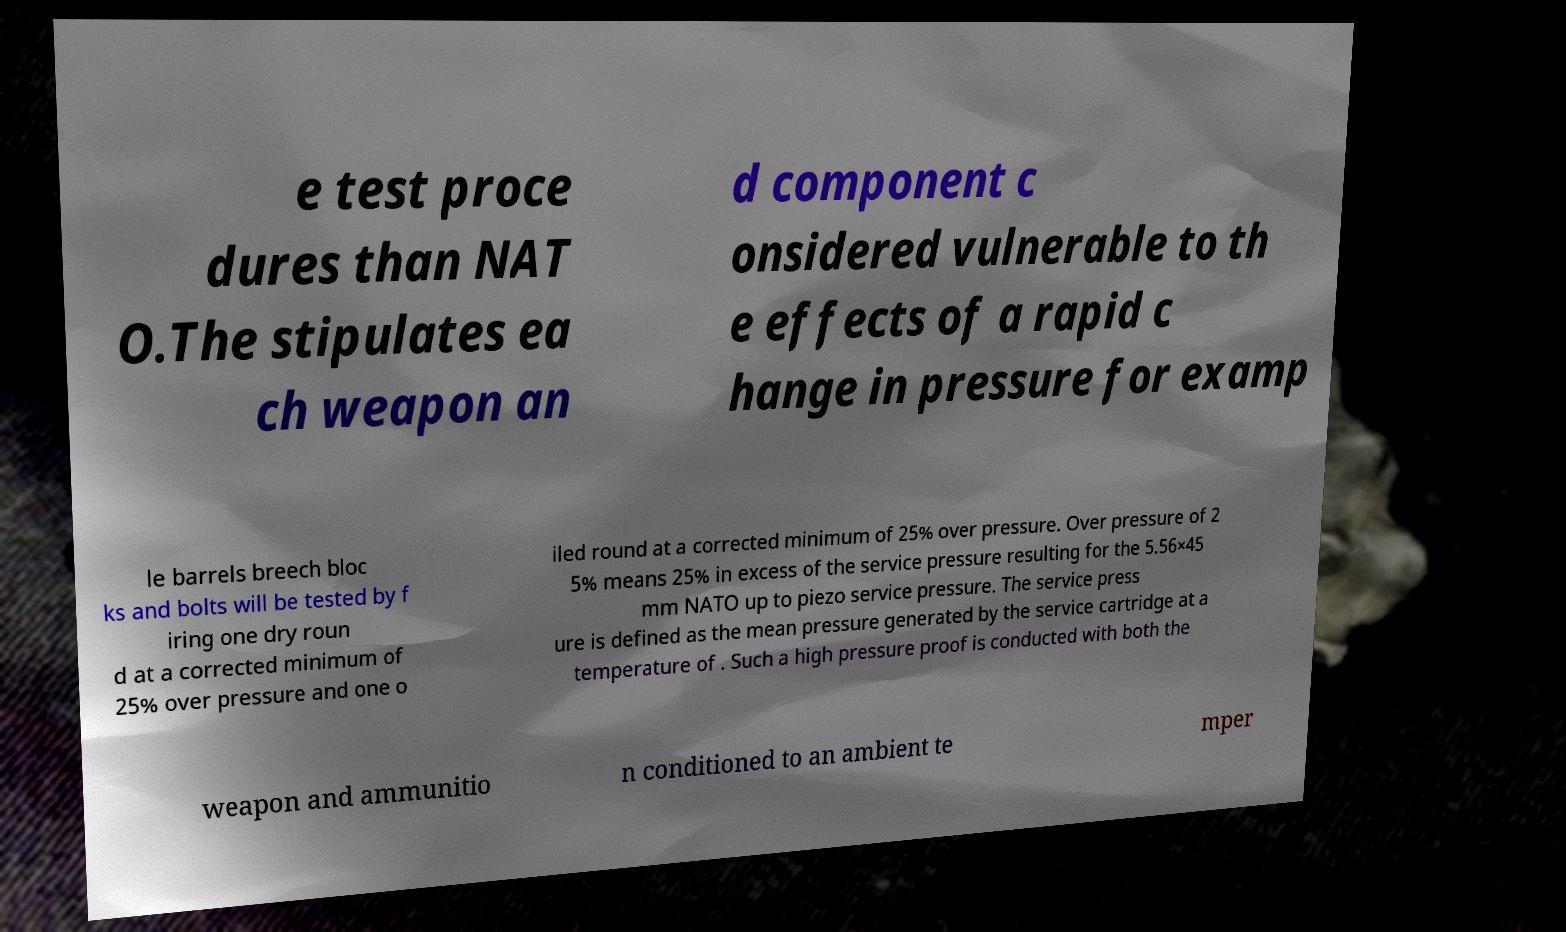There's text embedded in this image that I need extracted. Can you transcribe it verbatim? e test proce dures than NAT O.The stipulates ea ch weapon an d component c onsidered vulnerable to th e effects of a rapid c hange in pressure for examp le barrels breech bloc ks and bolts will be tested by f iring one dry roun d at a corrected minimum of 25% over pressure and one o iled round at a corrected minimum of 25% over pressure. Over pressure of 2 5% means 25% in excess of the service pressure resulting for the 5.56×45 mm NATO up to piezo service pressure. The service press ure is defined as the mean pressure generated by the service cartridge at a temperature of . Such a high pressure proof is conducted with both the weapon and ammunitio n conditioned to an ambient te mper 